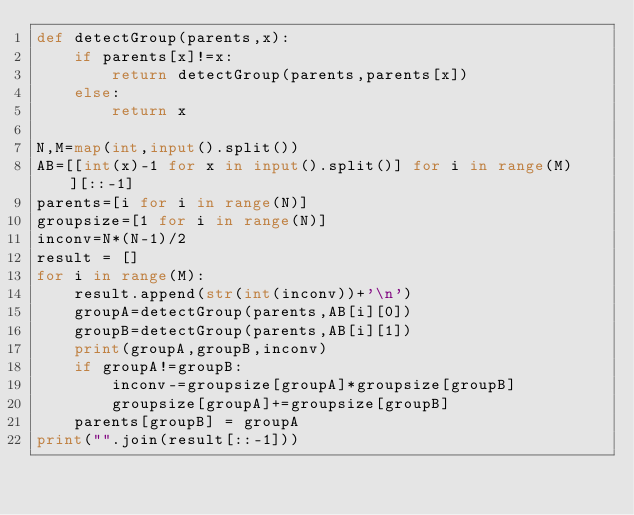Convert code to text. <code><loc_0><loc_0><loc_500><loc_500><_Python_>def detectGroup(parents,x):
    if parents[x]!=x:
        return detectGroup(parents,parents[x])
    else:
        return x
    
N,M=map(int,input().split())
AB=[[int(x)-1 for x in input().split()] for i in range(M)][::-1]
parents=[i for i in range(N)]
groupsize=[1 for i in range(N)]
inconv=N*(N-1)/2
result = []
for i in range(M):
    result.append(str(int(inconv))+'\n')
    groupA=detectGroup(parents,AB[i][0])
    groupB=detectGroup(parents,AB[i][1])
    print(groupA,groupB,inconv)
    if groupA!=groupB:
        inconv-=groupsize[groupA]*groupsize[groupB]
        groupsize[groupA]+=groupsize[groupB]
    parents[groupB] = groupA
print("".join(result[::-1]))</code> 